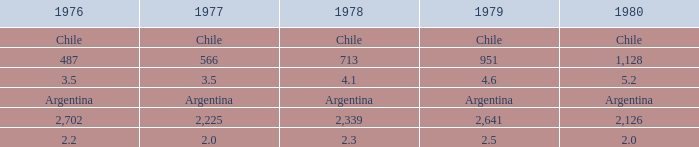What is 1977 when 1980 is chile? Chile. 